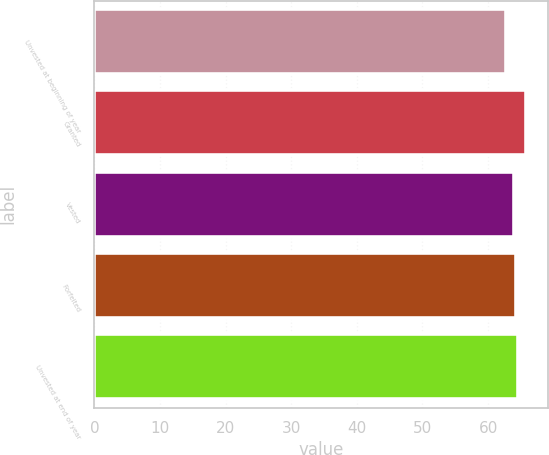Convert chart to OTSL. <chart><loc_0><loc_0><loc_500><loc_500><bar_chart><fcel>Unvested at beginning of year<fcel>Granted<fcel>Vested<fcel>Forfeited<fcel>Unvested at end of year<nl><fcel>62.75<fcel>65.79<fcel>63.92<fcel>64.22<fcel>64.52<nl></chart> 